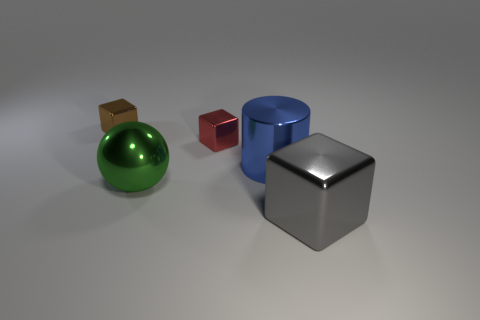There is a sphere; are there any gray metal objects right of it?
Your answer should be very brief. Yes. What is the color of the large metallic cube on the right side of the small thing right of the small thing that is left of the red cube?
Your response must be concise. Gray. What number of metal things are behind the big metallic cylinder and in front of the brown block?
Give a very brief answer. 1. What number of balls are either large yellow things or big blue metal objects?
Offer a terse response. 0. Are there any red metal blocks?
Provide a short and direct response. Yes. What number of other things are there of the same material as the red thing
Offer a very short reply. 4. What is the material of the cylinder that is the same size as the shiny sphere?
Your answer should be very brief. Metal. There is a small thing to the right of the green thing; is its shape the same as the brown object?
Ensure brevity in your answer.  Yes. Do the large cylinder and the large shiny block have the same color?
Offer a terse response. No. How many things are shiny cubes that are behind the blue thing or big gray cubes?
Keep it short and to the point. 3. 